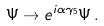<formula> <loc_0><loc_0><loc_500><loc_500>\Psi \rightarrow e ^ { i \alpha \gamma _ { 5 } } \Psi \, .</formula> 